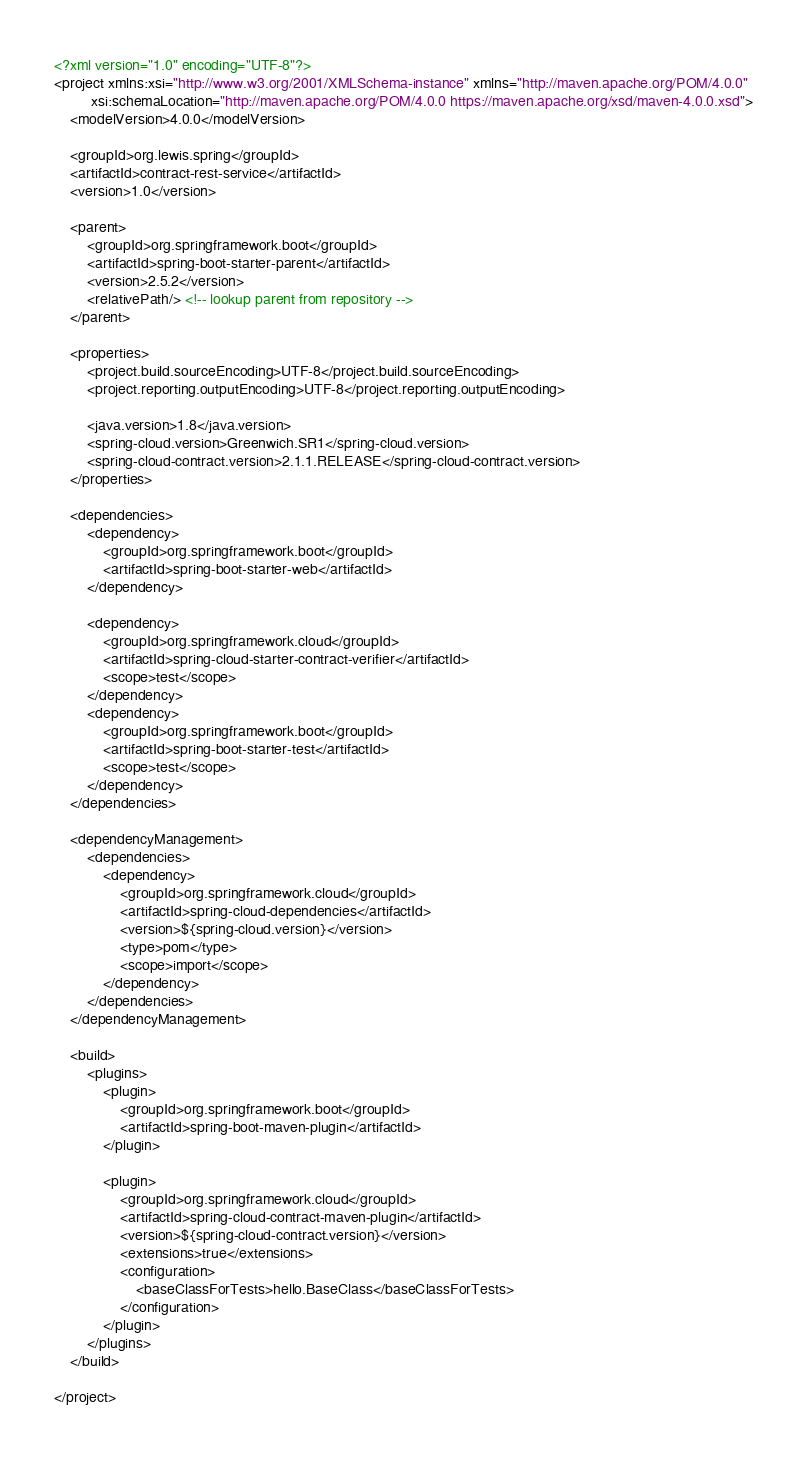Convert code to text. <code><loc_0><loc_0><loc_500><loc_500><_XML_><?xml version="1.0" encoding="UTF-8"?>
<project xmlns:xsi="http://www.w3.org/2001/XMLSchema-instance" xmlns="http://maven.apache.org/POM/4.0.0"
         xsi:schemaLocation="http://maven.apache.org/POM/4.0.0 https://maven.apache.org/xsd/maven-4.0.0.xsd">
    <modelVersion>4.0.0</modelVersion>

    <groupId>org.lewis.spring</groupId>
    <artifactId>contract-rest-service</artifactId>
    <version>1.0</version>

    <parent>
        <groupId>org.springframework.boot</groupId>
        <artifactId>spring-boot-starter-parent</artifactId>
        <version>2.5.2</version>
        <relativePath/> <!-- lookup parent from repository -->
    </parent>

    <properties>
        <project.build.sourceEncoding>UTF-8</project.build.sourceEncoding>
        <project.reporting.outputEncoding>UTF-8</project.reporting.outputEncoding>

        <java.version>1.8</java.version>
        <spring-cloud.version>Greenwich.SR1</spring-cloud.version>
        <spring-cloud-contract.version>2.1.1.RELEASE</spring-cloud-contract.version>
    </properties>

    <dependencies>
        <dependency>
            <groupId>org.springframework.boot</groupId>
            <artifactId>spring-boot-starter-web</artifactId>
        </dependency>

        <dependency>
            <groupId>org.springframework.cloud</groupId>
            <artifactId>spring-cloud-starter-contract-verifier</artifactId>
            <scope>test</scope>
        </dependency>
        <dependency>
            <groupId>org.springframework.boot</groupId>
            <artifactId>spring-boot-starter-test</artifactId>
            <scope>test</scope>
        </dependency>
    </dependencies>

    <dependencyManagement>
        <dependencies>
            <dependency>
                <groupId>org.springframework.cloud</groupId>
                <artifactId>spring-cloud-dependencies</artifactId>
                <version>${spring-cloud.version}</version>
                <type>pom</type>
                <scope>import</scope>
            </dependency>
        </dependencies>
    </dependencyManagement>

    <build>
        <plugins>
            <plugin>
                <groupId>org.springframework.boot</groupId>
                <artifactId>spring-boot-maven-plugin</artifactId>
            </plugin>

            <plugin>
                <groupId>org.springframework.cloud</groupId>
                <artifactId>spring-cloud-contract-maven-plugin</artifactId>
                <version>${spring-cloud-contract.version}</version>
                <extensions>true</extensions>
                <configuration>
                    <baseClassForTests>hello.BaseClass</baseClassForTests>
                </configuration>
            </plugin>
        </plugins>
    </build>

</project>
</code> 